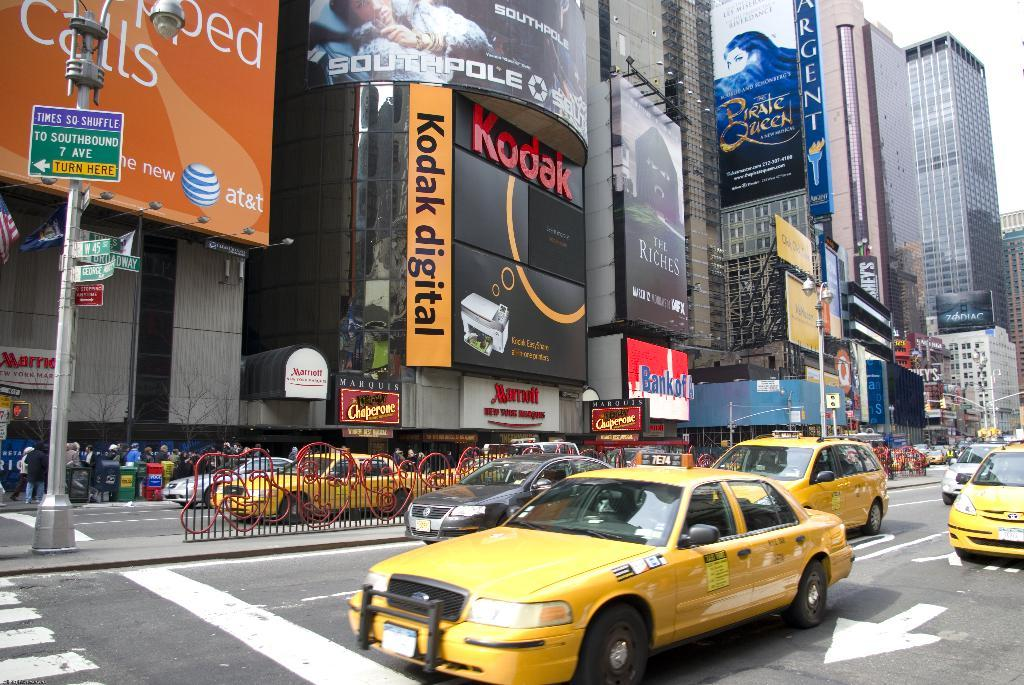<image>
Provide a brief description of the given image. An enormous Kodak Digital advertisement towers over the traffic on New York streets. 